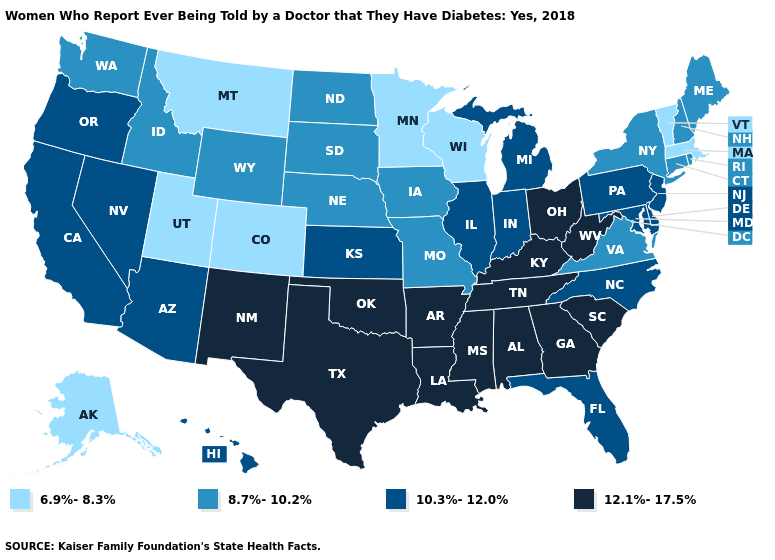Among the states that border Missouri , which have the lowest value?
Concise answer only. Iowa, Nebraska. What is the highest value in states that border Massachusetts?
Quick response, please. 8.7%-10.2%. What is the value of Illinois?
Be succinct. 10.3%-12.0%. What is the value of Maine?
Answer briefly. 8.7%-10.2%. Name the states that have a value in the range 6.9%-8.3%?
Short answer required. Alaska, Colorado, Massachusetts, Minnesota, Montana, Utah, Vermont, Wisconsin. Name the states that have a value in the range 12.1%-17.5%?
Concise answer only. Alabama, Arkansas, Georgia, Kentucky, Louisiana, Mississippi, New Mexico, Ohio, Oklahoma, South Carolina, Tennessee, Texas, West Virginia. Which states hav the highest value in the West?
Be succinct. New Mexico. Name the states that have a value in the range 12.1%-17.5%?
Concise answer only. Alabama, Arkansas, Georgia, Kentucky, Louisiana, Mississippi, New Mexico, Ohio, Oklahoma, South Carolina, Tennessee, Texas, West Virginia. Does New Mexico have the highest value in the West?
Keep it brief. Yes. What is the value of Connecticut?
Quick response, please. 8.7%-10.2%. Which states have the lowest value in the West?
Keep it brief. Alaska, Colorado, Montana, Utah. What is the value of Washington?
Be succinct. 8.7%-10.2%. Does Arkansas have the highest value in the USA?
Concise answer only. Yes. Is the legend a continuous bar?
Give a very brief answer. No. Does California have the lowest value in the West?
Give a very brief answer. No. 